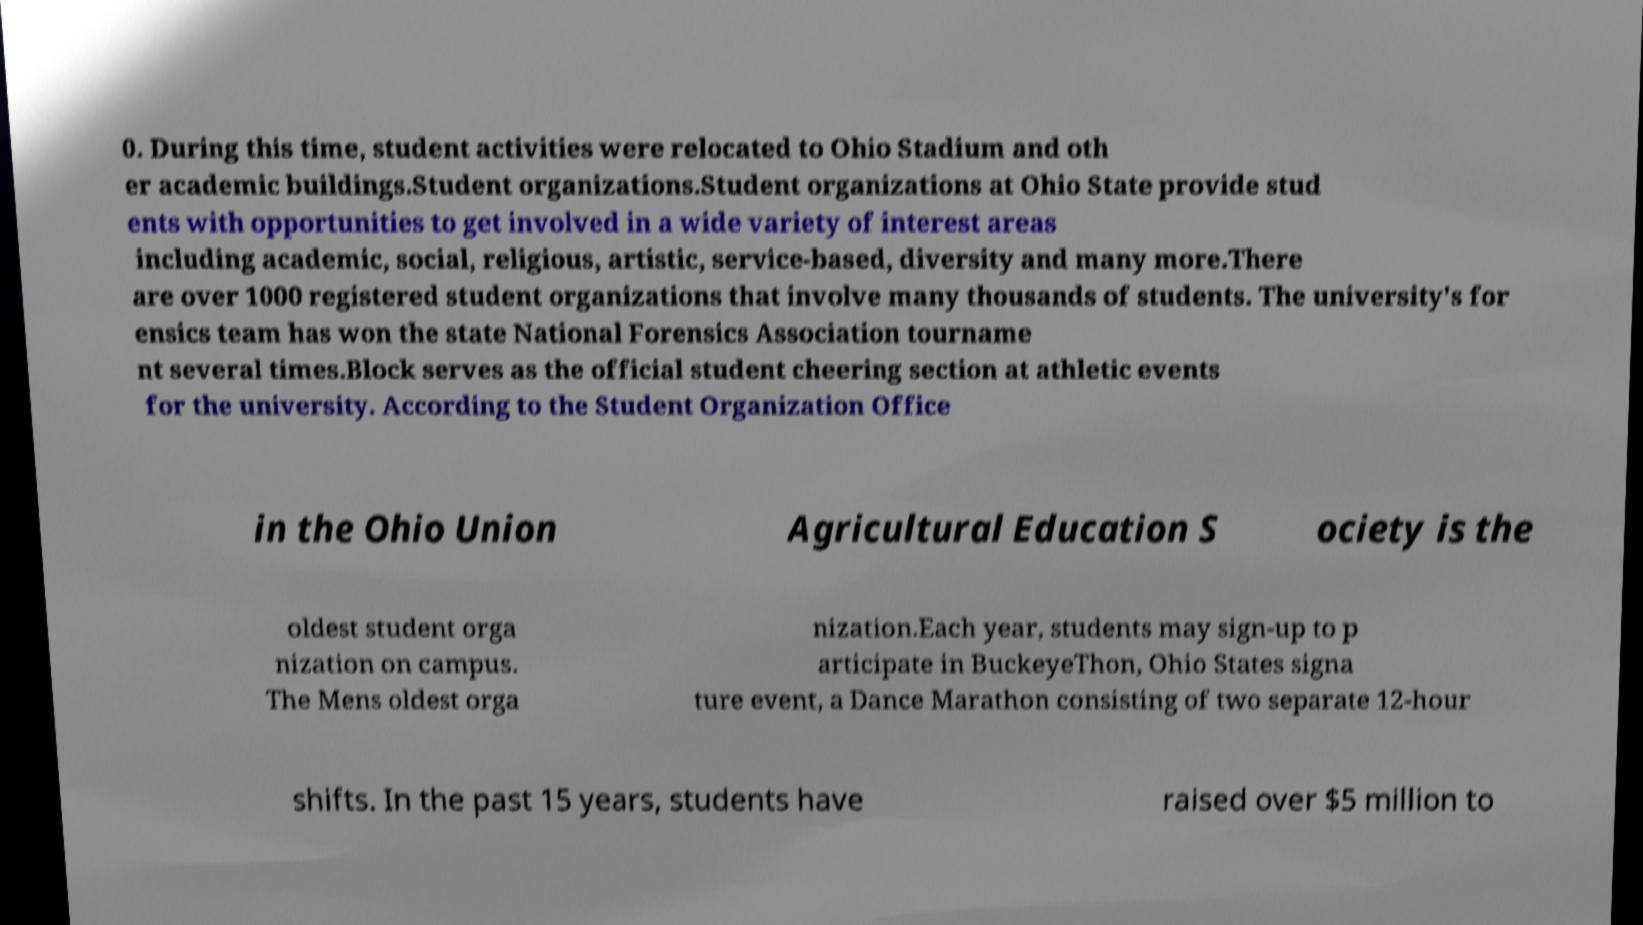Can you read and provide the text displayed in the image?This photo seems to have some interesting text. Can you extract and type it out for me? 0. During this time, student activities were relocated to Ohio Stadium and oth er academic buildings.Student organizations.Student organizations at Ohio State provide stud ents with opportunities to get involved in a wide variety of interest areas including academic, social, religious, artistic, service-based, diversity and many more.There are over 1000 registered student organizations that involve many thousands of students. The university's for ensics team has won the state National Forensics Association tourname nt several times.Block serves as the official student cheering section at athletic events for the university. According to the Student Organization Office in the Ohio Union Agricultural Education S ociety is the oldest student orga nization on campus. The Mens oldest orga nization.Each year, students may sign-up to p articipate in BuckeyeThon, Ohio States signa ture event, a Dance Marathon consisting of two separate 12-hour shifts. In the past 15 years, students have raised over $5 million to 